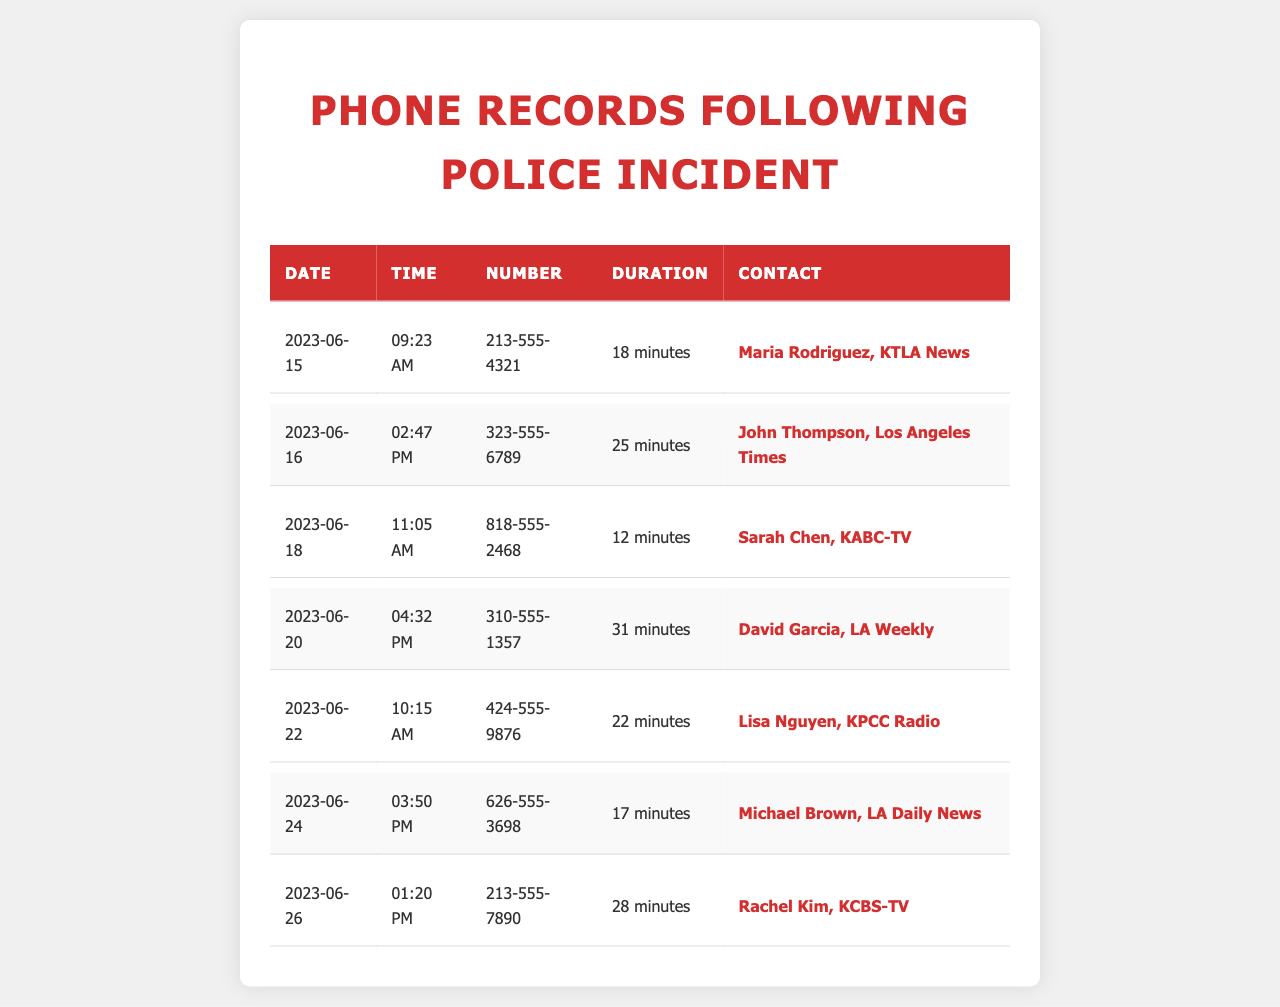what is the date of the first phone call listed? The first call is recorded on June 15, 2023.
Answer: June 15, 2023 how long was the longest phone call? The longest call was with David Garcia, lasting for 31 minutes.
Answer: 31 minutes who was contacted on June 20, 2023? The contact for June 20 is David Garcia from LA Weekly.
Answer: David Garcia, LA Weekly how many calls were made to local media outlets? There are seven calls made to local media outlets in total.
Answer: Seven which media outlet was contacted last? The last contact listed is Rachel Kim from KCBS-TV.
Answer: KCBS-TV what is the time of the call on June 22, 2023? The call on June 22 took place at 10:15 AM.
Answer: 10:15 AM which contact had the shortest duration call? The shortest duration call was with Sarah Chen, lasting 12 minutes.
Answer: Sarah Chen, 12 minutes how many different contacts are listed in the records? There are seven unique contacts listed in the records.
Answer: Seven 